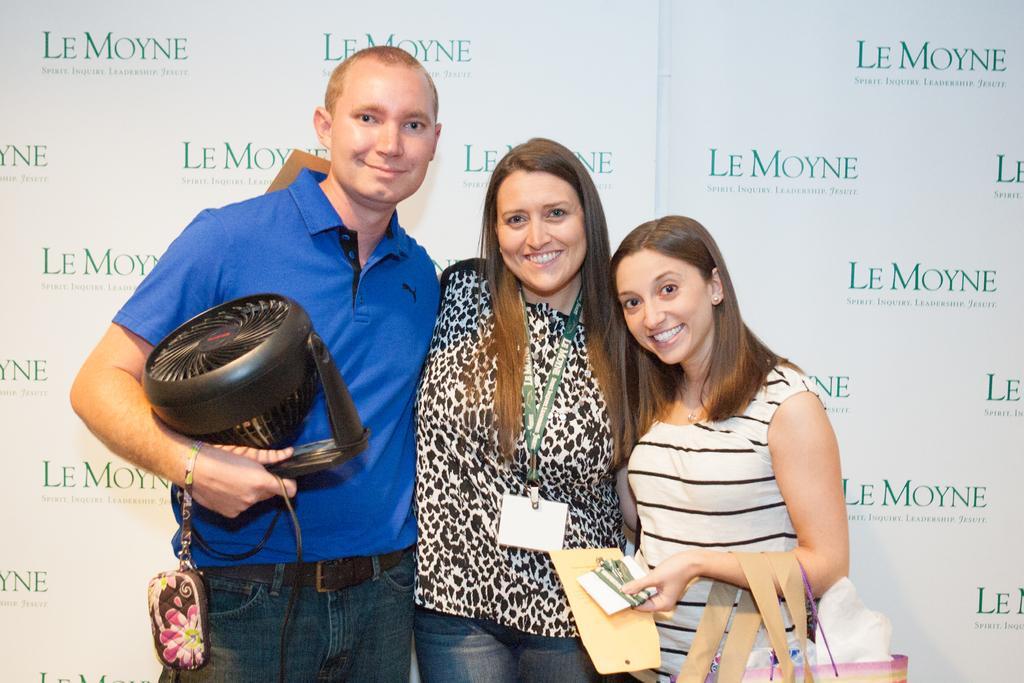Could you give a brief overview of what you see in this image? In this image I can see three people. In the background, I can see some text written on the wall. 